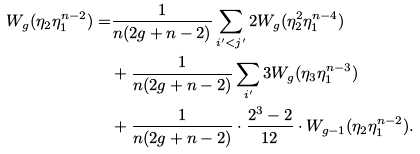<formula> <loc_0><loc_0><loc_500><loc_500>W _ { g } ( \eta _ { 2 } \eta _ { 1 } ^ { n - 2 } ) = & \frac { 1 } { n ( 2 g + n - 2 ) } \sum _ { i ^ { \prime } < j ^ { \prime } } 2 W _ { g } ( \eta _ { 2 } ^ { 2 } \eta _ { 1 } ^ { n - 4 } ) \\ & + \frac { 1 } { n ( 2 g + n - 2 ) } \sum _ { i ^ { \prime } } 3 W _ { g } ( \eta _ { 3 } \eta _ { 1 } ^ { n - 3 } ) \\ & + \frac { 1 } { n ( 2 g + n - 2 ) } \cdot \frac { 2 ^ { 3 } - 2 } { 1 2 } \cdot W _ { g - 1 } ( \eta _ { 2 } \eta _ { 1 } ^ { n - 2 } ) .</formula> 